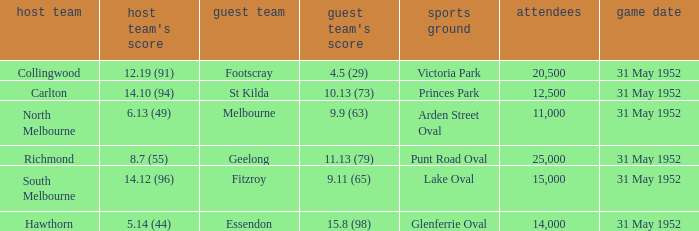When was the game when Footscray was the away team? 31 May 1952. Parse the full table. {'header': ['host team', "host team's score", 'guest team', "guest team's score", 'sports ground', 'attendees', 'game date'], 'rows': [['Collingwood', '12.19 (91)', 'Footscray', '4.5 (29)', 'Victoria Park', '20,500', '31 May 1952'], ['Carlton', '14.10 (94)', 'St Kilda', '10.13 (73)', 'Princes Park', '12,500', '31 May 1952'], ['North Melbourne', '6.13 (49)', 'Melbourne', '9.9 (63)', 'Arden Street Oval', '11,000', '31 May 1952'], ['Richmond', '8.7 (55)', 'Geelong', '11.13 (79)', 'Punt Road Oval', '25,000', '31 May 1952'], ['South Melbourne', '14.12 (96)', 'Fitzroy', '9.11 (65)', 'Lake Oval', '15,000', '31 May 1952'], ['Hawthorn', '5.14 (44)', 'Essendon', '15.8 (98)', 'Glenferrie Oval', '14,000', '31 May 1952']]} 